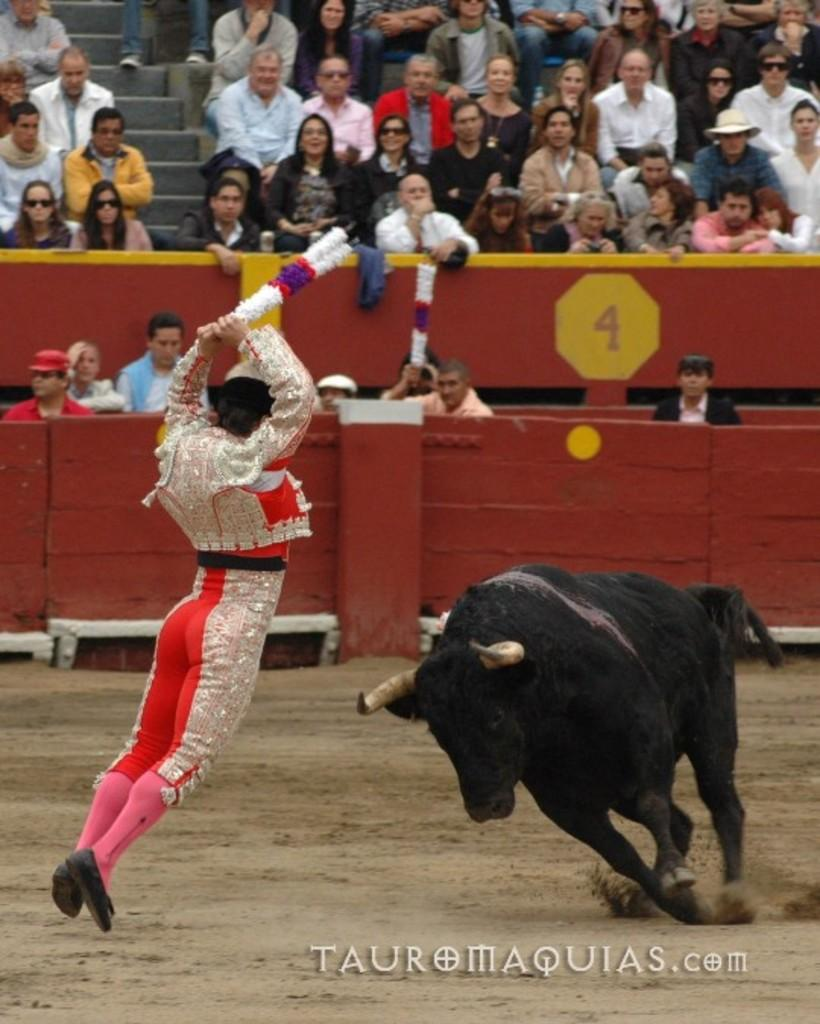What is the color of the bull in the image? The bull in the image is black. Where is the bull located in the image? The bull is on the right side of the image. Can you describe the person in the image? There is a person in the image, but their description is not provided in the facts. What are the people in the background doing? The people in the background are sitting and watching the bull. What type of quiver is the bull carrying in the image? There is no quiver present in the image; the bull is not carrying any object. What kind of structure can be seen in the background of the image? The facts do not mention any structure in the background of the image. 